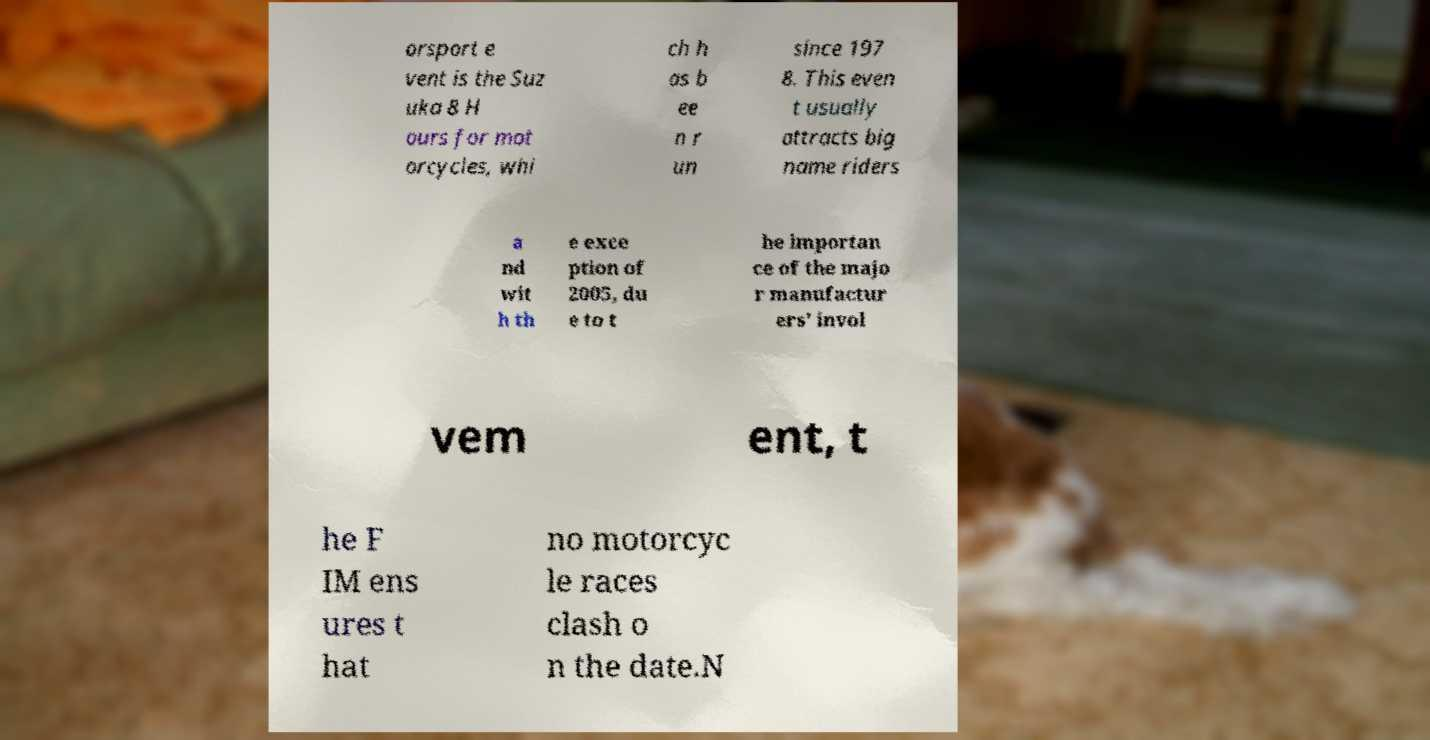Could you assist in decoding the text presented in this image and type it out clearly? orsport e vent is the Suz uka 8 H ours for mot orcycles, whi ch h as b ee n r un since 197 8. This even t usually attracts big name riders a nd wit h th e exce ption of 2005, du e to t he importan ce of the majo r manufactur ers' invol vem ent, t he F IM ens ures t hat no motorcyc le races clash o n the date.N 